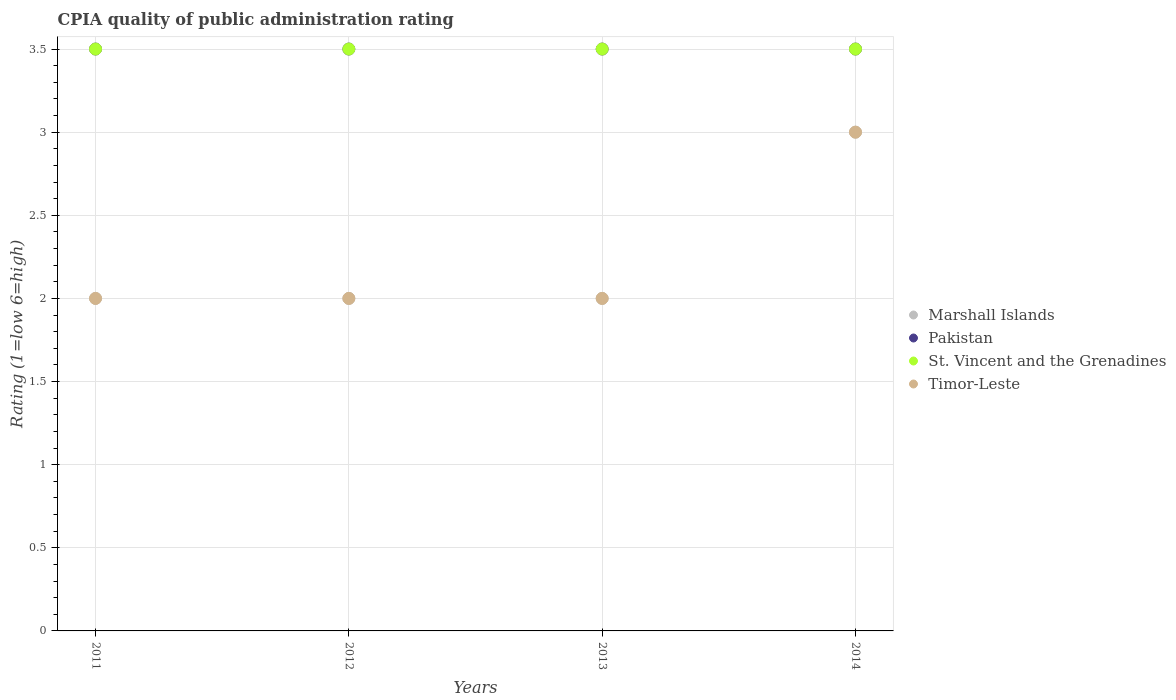How many different coloured dotlines are there?
Your response must be concise. 4. Is the number of dotlines equal to the number of legend labels?
Provide a succinct answer. Yes. What is the CPIA rating in Pakistan in 2012?
Your answer should be compact. 3.5. Across all years, what is the minimum CPIA rating in Timor-Leste?
Give a very brief answer. 2. In which year was the CPIA rating in Pakistan maximum?
Keep it short and to the point. 2011. In which year was the CPIA rating in St. Vincent and the Grenadines minimum?
Ensure brevity in your answer.  2011. What is the difference between the CPIA rating in Pakistan in 2011 and that in 2013?
Ensure brevity in your answer.  0. What is the difference between the CPIA rating in St. Vincent and the Grenadines in 2011 and the CPIA rating in Timor-Leste in 2012?
Keep it short and to the point. 1.5. What is the ratio of the CPIA rating in Marshall Islands in 2011 to that in 2013?
Make the answer very short. 1. Is the difference between the CPIA rating in Timor-Leste in 2012 and 2013 greater than the difference between the CPIA rating in Marshall Islands in 2012 and 2013?
Provide a short and direct response. No. In how many years, is the CPIA rating in St. Vincent and the Grenadines greater than the average CPIA rating in St. Vincent and the Grenadines taken over all years?
Make the answer very short. 0. Is it the case that in every year, the sum of the CPIA rating in Timor-Leste and CPIA rating in Pakistan  is greater than the sum of CPIA rating in St. Vincent and the Grenadines and CPIA rating in Marshall Islands?
Your answer should be very brief. Yes. Does the CPIA rating in Marshall Islands monotonically increase over the years?
Your response must be concise. No. Is the CPIA rating in Marshall Islands strictly greater than the CPIA rating in Timor-Leste over the years?
Offer a very short reply. No. Is the CPIA rating in Timor-Leste strictly less than the CPIA rating in Marshall Islands over the years?
Your answer should be very brief. No. How many dotlines are there?
Your response must be concise. 4. How many years are there in the graph?
Give a very brief answer. 4. Are the values on the major ticks of Y-axis written in scientific E-notation?
Provide a succinct answer. No. Does the graph contain any zero values?
Offer a terse response. No. How are the legend labels stacked?
Ensure brevity in your answer.  Vertical. What is the title of the graph?
Give a very brief answer. CPIA quality of public administration rating. What is the label or title of the X-axis?
Make the answer very short. Years. What is the Rating (1=low 6=high) of Marshall Islands in 2011?
Keep it short and to the point. 2. What is the Rating (1=low 6=high) of St. Vincent and the Grenadines in 2011?
Your response must be concise. 3.5. What is the Rating (1=low 6=high) in Timor-Leste in 2011?
Ensure brevity in your answer.  2. What is the Rating (1=low 6=high) of Marshall Islands in 2012?
Your answer should be very brief. 2. What is the Rating (1=low 6=high) of Pakistan in 2012?
Provide a succinct answer. 3.5. What is the Rating (1=low 6=high) of St. Vincent and the Grenadines in 2012?
Provide a succinct answer. 3.5. What is the Rating (1=low 6=high) in Pakistan in 2013?
Keep it short and to the point. 3.5. What is the Rating (1=low 6=high) in Pakistan in 2014?
Your response must be concise. 3.5. What is the Rating (1=low 6=high) in St. Vincent and the Grenadines in 2014?
Keep it short and to the point. 3.5. Across all years, what is the maximum Rating (1=low 6=high) of Pakistan?
Your answer should be very brief. 3.5. Across all years, what is the maximum Rating (1=low 6=high) of Timor-Leste?
Your answer should be compact. 3. Across all years, what is the minimum Rating (1=low 6=high) in Marshall Islands?
Provide a short and direct response. 2. What is the total Rating (1=low 6=high) of Marshall Islands in the graph?
Keep it short and to the point. 9. What is the total Rating (1=low 6=high) in Pakistan in the graph?
Your response must be concise. 14. What is the difference between the Rating (1=low 6=high) in Pakistan in 2011 and that in 2012?
Your answer should be compact. 0. What is the difference between the Rating (1=low 6=high) of St. Vincent and the Grenadines in 2011 and that in 2012?
Make the answer very short. 0. What is the difference between the Rating (1=low 6=high) in Timor-Leste in 2011 and that in 2012?
Your answer should be very brief. 0. What is the difference between the Rating (1=low 6=high) of St. Vincent and the Grenadines in 2011 and that in 2013?
Keep it short and to the point. 0. What is the difference between the Rating (1=low 6=high) of Timor-Leste in 2011 and that in 2013?
Provide a short and direct response. 0. What is the difference between the Rating (1=low 6=high) of Marshall Islands in 2011 and that in 2014?
Your response must be concise. -1. What is the difference between the Rating (1=low 6=high) of Pakistan in 2011 and that in 2014?
Give a very brief answer. 0. What is the difference between the Rating (1=low 6=high) of Marshall Islands in 2012 and that in 2013?
Provide a short and direct response. 0. What is the difference between the Rating (1=low 6=high) in Pakistan in 2012 and that in 2013?
Your answer should be compact. 0. What is the difference between the Rating (1=low 6=high) in St. Vincent and the Grenadines in 2012 and that in 2013?
Offer a very short reply. 0. What is the difference between the Rating (1=low 6=high) of Marshall Islands in 2012 and that in 2014?
Offer a terse response. -1. What is the difference between the Rating (1=low 6=high) of Pakistan in 2012 and that in 2014?
Your answer should be very brief. 0. What is the difference between the Rating (1=low 6=high) in St. Vincent and the Grenadines in 2013 and that in 2014?
Provide a succinct answer. 0. What is the difference between the Rating (1=low 6=high) of Marshall Islands in 2011 and the Rating (1=low 6=high) of Timor-Leste in 2012?
Offer a terse response. 0. What is the difference between the Rating (1=low 6=high) of Pakistan in 2011 and the Rating (1=low 6=high) of Timor-Leste in 2012?
Your answer should be compact. 1.5. What is the difference between the Rating (1=low 6=high) in St. Vincent and the Grenadines in 2011 and the Rating (1=low 6=high) in Timor-Leste in 2012?
Provide a short and direct response. 1.5. What is the difference between the Rating (1=low 6=high) in Marshall Islands in 2011 and the Rating (1=low 6=high) in Pakistan in 2013?
Your response must be concise. -1.5. What is the difference between the Rating (1=low 6=high) of Marshall Islands in 2011 and the Rating (1=low 6=high) of St. Vincent and the Grenadines in 2013?
Provide a short and direct response. -1.5. What is the difference between the Rating (1=low 6=high) in Marshall Islands in 2011 and the Rating (1=low 6=high) in Timor-Leste in 2013?
Make the answer very short. 0. What is the difference between the Rating (1=low 6=high) of Pakistan in 2011 and the Rating (1=low 6=high) of St. Vincent and the Grenadines in 2013?
Provide a short and direct response. 0. What is the difference between the Rating (1=low 6=high) in St. Vincent and the Grenadines in 2011 and the Rating (1=low 6=high) in Timor-Leste in 2013?
Your response must be concise. 1.5. What is the difference between the Rating (1=low 6=high) in Marshall Islands in 2011 and the Rating (1=low 6=high) in Pakistan in 2014?
Provide a short and direct response. -1.5. What is the difference between the Rating (1=low 6=high) in Marshall Islands in 2011 and the Rating (1=low 6=high) in St. Vincent and the Grenadines in 2014?
Your response must be concise. -1.5. What is the difference between the Rating (1=low 6=high) in Marshall Islands in 2011 and the Rating (1=low 6=high) in Timor-Leste in 2014?
Offer a very short reply. -1. What is the difference between the Rating (1=low 6=high) of Pakistan in 2011 and the Rating (1=low 6=high) of Timor-Leste in 2014?
Provide a succinct answer. 0.5. What is the difference between the Rating (1=low 6=high) in Marshall Islands in 2012 and the Rating (1=low 6=high) in Pakistan in 2013?
Offer a terse response. -1.5. What is the difference between the Rating (1=low 6=high) of Marshall Islands in 2012 and the Rating (1=low 6=high) of Timor-Leste in 2013?
Provide a short and direct response. 0. What is the difference between the Rating (1=low 6=high) in Pakistan in 2012 and the Rating (1=low 6=high) in St. Vincent and the Grenadines in 2013?
Offer a terse response. 0. What is the difference between the Rating (1=low 6=high) in St. Vincent and the Grenadines in 2012 and the Rating (1=low 6=high) in Timor-Leste in 2013?
Provide a succinct answer. 1.5. What is the difference between the Rating (1=low 6=high) in Marshall Islands in 2012 and the Rating (1=low 6=high) in St. Vincent and the Grenadines in 2014?
Provide a succinct answer. -1.5. What is the difference between the Rating (1=low 6=high) of Marshall Islands in 2013 and the Rating (1=low 6=high) of St. Vincent and the Grenadines in 2014?
Ensure brevity in your answer.  -1.5. What is the difference between the Rating (1=low 6=high) in Pakistan in 2013 and the Rating (1=low 6=high) in St. Vincent and the Grenadines in 2014?
Offer a very short reply. 0. What is the difference between the Rating (1=low 6=high) of St. Vincent and the Grenadines in 2013 and the Rating (1=low 6=high) of Timor-Leste in 2014?
Give a very brief answer. 0.5. What is the average Rating (1=low 6=high) of Marshall Islands per year?
Your answer should be very brief. 2.25. What is the average Rating (1=low 6=high) of Timor-Leste per year?
Provide a succinct answer. 2.25. In the year 2011, what is the difference between the Rating (1=low 6=high) in Marshall Islands and Rating (1=low 6=high) in Timor-Leste?
Offer a very short reply. 0. In the year 2011, what is the difference between the Rating (1=low 6=high) of Pakistan and Rating (1=low 6=high) of Timor-Leste?
Ensure brevity in your answer.  1.5. In the year 2011, what is the difference between the Rating (1=low 6=high) in St. Vincent and the Grenadines and Rating (1=low 6=high) in Timor-Leste?
Make the answer very short. 1.5. In the year 2012, what is the difference between the Rating (1=low 6=high) of Marshall Islands and Rating (1=low 6=high) of St. Vincent and the Grenadines?
Ensure brevity in your answer.  -1.5. In the year 2012, what is the difference between the Rating (1=low 6=high) of Marshall Islands and Rating (1=low 6=high) of Timor-Leste?
Keep it short and to the point. 0. In the year 2012, what is the difference between the Rating (1=low 6=high) in Pakistan and Rating (1=low 6=high) in St. Vincent and the Grenadines?
Keep it short and to the point. 0. In the year 2013, what is the difference between the Rating (1=low 6=high) of Marshall Islands and Rating (1=low 6=high) of Pakistan?
Make the answer very short. -1.5. In the year 2013, what is the difference between the Rating (1=low 6=high) in Marshall Islands and Rating (1=low 6=high) in St. Vincent and the Grenadines?
Your answer should be compact. -1.5. In the year 2013, what is the difference between the Rating (1=low 6=high) in Pakistan and Rating (1=low 6=high) in St. Vincent and the Grenadines?
Offer a very short reply. 0. In the year 2014, what is the difference between the Rating (1=low 6=high) in Marshall Islands and Rating (1=low 6=high) in St. Vincent and the Grenadines?
Provide a short and direct response. -0.5. In the year 2014, what is the difference between the Rating (1=low 6=high) of Pakistan and Rating (1=low 6=high) of St. Vincent and the Grenadines?
Offer a very short reply. 0. What is the ratio of the Rating (1=low 6=high) of Pakistan in 2011 to that in 2012?
Make the answer very short. 1. What is the ratio of the Rating (1=low 6=high) of St. Vincent and the Grenadines in 2011 to that in 2012?
Keep it short and to the point. 1. What is the ratio of the Rating (1=low 6=high) in St. Vincent and the Grenadines in 2011 to that in 2013?
Provide a succinct answer. 1. What is the ratio of the Rating (1=low 6=high) in Timor-Leste in 2011 to that in 2013?
Your answer should be very brief. 1. What is the ratio of the Rating (1=low 6=high) of Timor-Leste in 2011 to that in 2014?
Offer a very short reply. 0.67. What is the ratio of the Rating (1=low 6=high) of Marshall Islands in 2012 to that in 2013?
Provide a succinct answer. 1. What is the ratio of the Rating (1=low 6=high) of St. Vincent and the Grenadines in 2012 to that in 2013?
Make the answer very short. 1. What is the ratio of the Rating (1=low 6=high) in Timor-Leste in 2012 to that in 2013?
Your answer should be very brief. 1. What is the ratio of the Rating (1=low 6=high) in Marshall Islands in 2012 to that in 2014?
Your answer should be very brief. 0.67. What is the ratio of the Rating (1=low 6=high) of Pakistan in 2012 to that in 2014?
Keep it short and to the point. 1. What is the ratio of the Rating (1=low 6=high) of St. Vincent and the Grenadines in 2012 to that in 2014?
Your response must be concise. 1. What is the ratio of the Rating (1=low 6=high) of Pakistan in 2013 to that in 2014?
Offer a terse response. 1. What is the ratio of the Rating (1=low 6=high) in St. Vincent and the Grenadines in 2013 to that in 2014?
Make the answer very short. 1. What is the ratio of the Rating (1=low 6=high) of Timor-Leste in 2013 to that in 2014?
Give a very brief answer. 0.67. What is the difference between the highest and the lowest Rating (1=low 6=high) in St. Vincent and the Grenadines?
Offer a terse response. 0. 